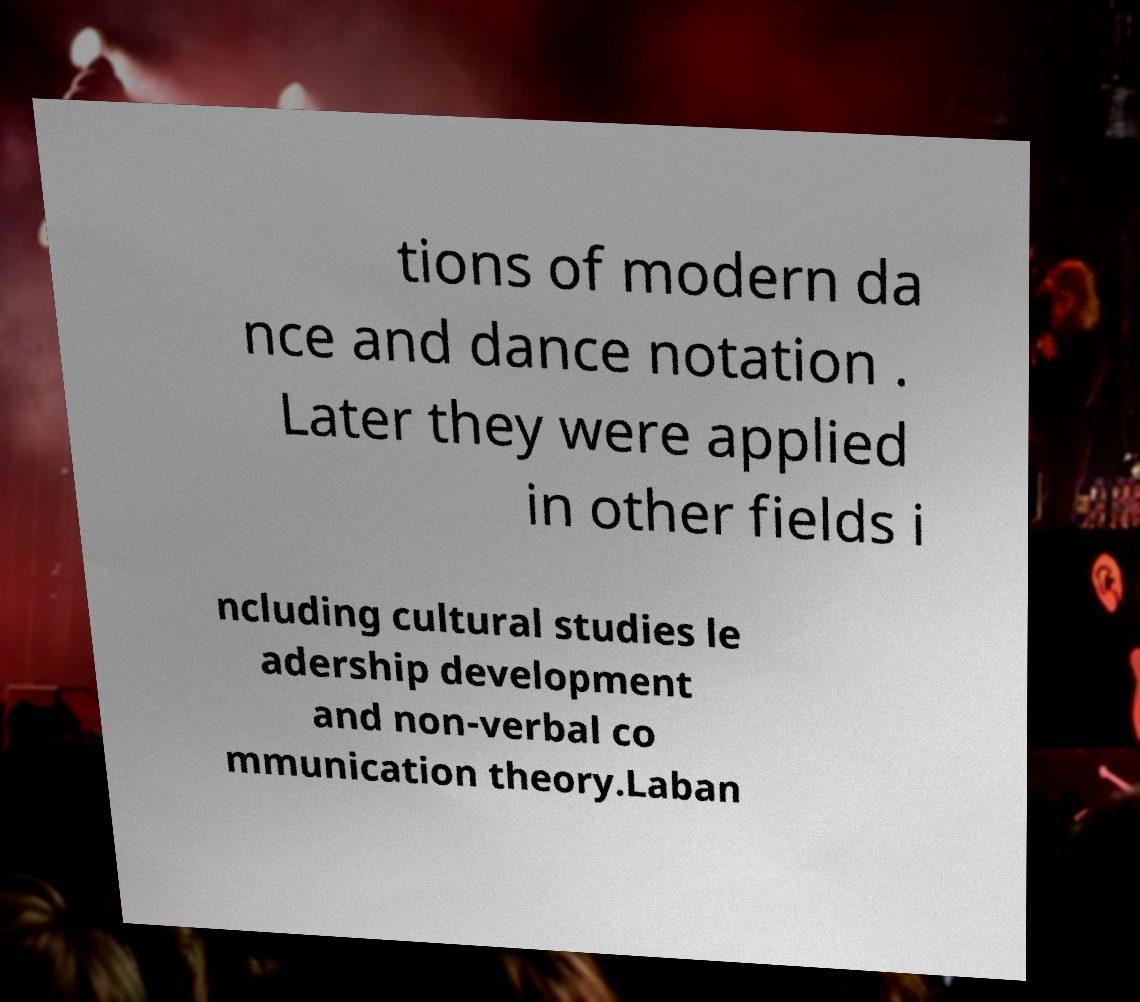Could you extract and type out the text from this image? tions of modern da nce and dance notation . Later they were applied in other fields i ncluding cultural studies le adership development and non-verbal co mmunication theory.Laban 